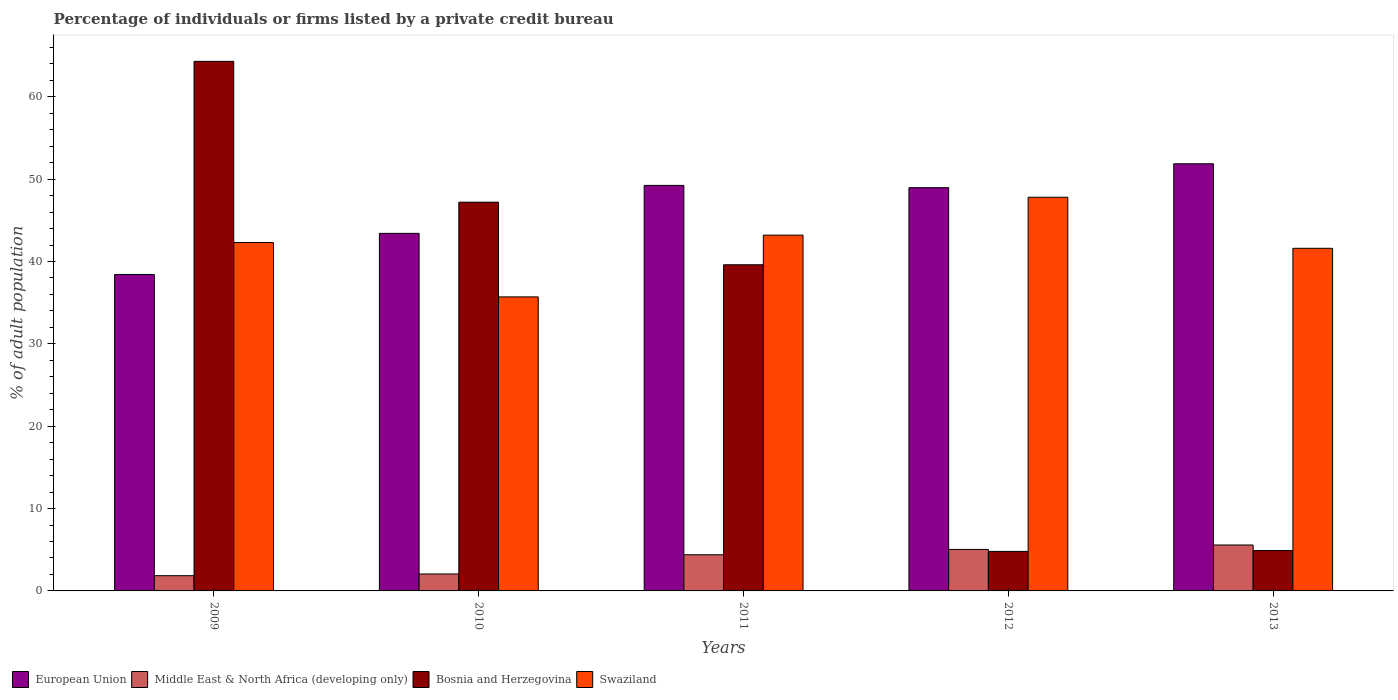How many groups of bars are there?
Your answer should be compact. 5. How many bars are there on the 3rd tick from the left?
Give a very brief answer. 4. How many bars are there on the 3rd tick from the right?
Keep it short and to the point. 4. What is the label of the 5th group of bars from the left?
Provide a short and direct response. 2013. What is the percentage of population listed by a private credit bureau in Swaziland in 2012?
Offer a very short reply. 47.8. Across all years, what is the maximum percentage of population listed by a private credit bureau in Bosnia and Herzegovina?
Provide a succinct answer. 64.3. In which year was the percentage of population listed by a private credit bureau in Swaziland maximum?
Provide a succinct answer. 2012. What is the total percentage of population listed by a private credit bureau in Bosnia and Herzegovina in the graph?
Make the answer very short. 160.8. What is the difference between the percentage of population listed by a private credit bureau in Middle East & North Africa (developing only) in 2012 and that in 2013?
Your response must be concise. -0.54. What is the difference between the percentage of population listed by a private credit bureau in European Union in 2010 and the percentage of population listed by a private credit bureau in Swaziland in 2009?
Provide a short and direct response. 1.11. What is the average percentage of population listed by a private credit bureau in Swaziland per year?
Your answer should be very brief. 42.12. In the year 2011, what is the difference between the percentage of population listed by a private credit bureau in Swaziland and percentage of population listed by a private credit bureau in European Union?
Make the answer very short. -6.04. In how many years, is the percentage of population listed by a private credit bureau in Bosnia and Herzegovina greater than 16 %?
Provide a short and direct response. 3. What is the ratio of the percentage of population listed by a private credit bureau in Swaziland in 2012 to that in 2013?
Ensure brevity in your answer.  1.15. Is the percentage of population listed by a private credit bureau in Middle East & North Africa (developing only) in 2010 less than that in 2012?
Your answer should be compact. Yes. Is the difference between the percentage of population listed by a private credit bureau in Swaziland in 2010 and 2013 greater than the difference between the percentage of population listed by a private credit bureau in European Union in 2010 and 2013?
Your answer should be compact. Yes. What is the difference between the highest and the second highest percentage of population listed by a private credit bureau in European Union?
Your response must be concise. 2.62. What is the difference between the highest and the lowest percentage of population listed by a private credit bureau in Middle East & North Africa (developing only)?
Ensure brevity in your answer.  3.73. In how many years, is the percentage of population listed by a private credit bureau in European Union greater than the average percentage of population listed by a private credit bureau in European Union taken over all years?
Ensure brevity in your answer.  3. Is the sum of the percentage of population listed by a private credit bureau in Swaziland in 2009 and 2011 greater than the maximum percentage of population listed by a private credit bureau in Bosnia and Herzegovina across all years?
Provide a short and direct response. Yes. Is it the case that in every year, the sum of the percentage of population listed by a private credit bureau in Bosnia and Herzegovina and percentage of population listed by a private credit bureau in European Union is greater than the sum of percentage of population listed by a private credit bureau in Swaziland and percentage of population listed by a private credit bureau in Middle East & North Africa (developing only)?
Provide a short and direct response. No. Are all the bars in the graph horizontal?
Offer a very short reply. No. What is the difference between two consecutive major ticks on the Y-axis?
Keep it short and to the point. 10. What is the title of the graph?
Provide a succinct answer. Percentage of individuals or firms listed by a private credit bureau. What is the label or title of the X-axis?
Give a very brief answer. Years. What is the label or title of the Y-axis?
Keep it short and to the point. % of adult population. What is the % of adult population of European Union in 2009?
Provide a short and direct response. 38.42. What is the % of adult population in Middle East & North Africa (developing only) in 2009?
Your answer should be very brief. 1.85. What is the % of adult population of Bosnia and Herzegovina in 2009?
Your response must be concise. 64.3. What is the % of adult population of Swaziland in 2009?
Offer a terse response. 42.3. What is the % of adult population in European Union in 2010?
Give a very brief answer. 43.41. What is the % of adult population in Middle East & North Africa (developing only) in 2010?
Keep it short and to the point. 2.06. What is the % of adult population of Bosnia and Herzegovina in 2010?
Make the answer very short. 47.2. What is the % of adult population of Swaziland in 2010?
Provide a succinct answer. 35.7. What is the % of adult population in European Union in 2011?
Make the answer very short. 49.24. What is the % of adult population of Middle East & North Africa (developing only) in 2011?
Make the answer very short. 4.39. What is the % of adult population in Bosnia and Herzegovina in 2011?
Provide a short and direct response. 39.6. What is the % of adult population in Swaziland in 2011?
Provide a succinct answer. 43.2. What is the % of adult population in European Union in 2012?
Offer a very short reply. 48.96. What is the % of adult population of Middle East & North Africa (developing only) in 2012?
Give a very brief answer. 5.04. What is the % of adult population of Bosnia and Herzegovina in 2012?
Provide a succinct answer. 4.8. What is the % of adult population of Swaziland in 2012?
Offer a very short reply. 47.8. What is the % of adult population in European Union in 2013?
Provide a succinct answer. 51.86. What is the % of adult population of Middle East & North Africa (developing only) in 2013?
Your response must be concise. 5.58. What is the % of adult population of Swaziland in 2013?
Your response must be concise. 41.6. Across all years, what is the maximum % of adult population of European Union?
Provide a succinct answer. 51.86. Across all years, what is the maximum % of adult population in Middle East & North Africa (developing only)?
Provide a short and direct response. 5.58. Across all years, what is the maximum % of adult population of Bosnia and Herzegovina?
Your answer should be compact. 64.3. Across all years, what is the maximum % of adult population of Swaziland?
Offer a very short reply. 47.8. Across all years, what is the minimum % of adult population of European Union?
Offer a very short reply. 38.42. Across all years, what is the minimum % of adult population in Middle East & North Africa (developing only)?
Offer a very short reply. 1.85. Across all years, what is the minimum % of adult population of Bosnia and Herzegovina?
Provide a short and direct response. 4.8. Across all years, what is the minimum % of adult population of Swaziland?
Offer a terse response. 35.7. What is the total % of adult population in European Union in the graph?
Keep it short and to the point. 231.9. What is the total % of adult population of Middle East & North Africa (developing only) in the graph?
Keep it short and to the point. 18.92. What is the total % of adult population of Bosnia and Herzegovina in the graph?
Give a very brief answer. 160.8. What is the total % of adult population of Swaziland in the graph?
Keep it short and to the point. 210.6. What is the difference between the % of adult population of European Union in 2009 and that in 2010?
Offer a very short reply. -4.99. What is the difference between the % of adult population in Middle East & North Africa (developing only) in 2009 and that in 2010?
Keep it short and to the point. -0.21. What is the difference between the % of adult population in Bosnia and Herzegovina in 2009 and that in 2010?
Your answer should be compact. 17.1. What is the difference between the % of adult population of European Union in 2009 and that in 2011?
Your answer should be compact. -10.82. What is the difference between the % of adult population of Middle East & North Africa (developing only) in 2009 and that in 2011?
Keep it short and to the point. -2.54. What is the difference between the % of adult population in Bosnia and Herzegovina in 2009 and that in 2011?
Ensure brevity in your answer.  24.7. What is the difference between the % of adult population of European Union in 2009 and that in 2012?
Your answer should be very brief. -10.54. What is the difference between the % of adult population in Middle East & North Africa (developing only) in 2009 and that in 2012?
Provide a succinct answer. -3.19. What is the difference between the % of adult population in Bosnia and Herzegovina in 2009 and that in 2012?
Provide a succinct answer. 59.5. What is the difference between the % of adult population in Swaziland in 2009 and that in 2012?
Give a very brief answer. -5.5. What is the difference between the % of adult population of European Union in 2009 and that in 2013?
Give a very brief answer. -13.44. What is the difference between the % of adult population of Middle East & North Africa (developing only) in 2009 and that in 2013?
Make the answer very short. -3.73. What is the difference between the % of adult population in Bosnia and Herzegovina in 2009 and that in 2013?
Make the answer very short. 59.4. What is the difference between the % of adult population of European Union in 2010 and that in 2011?
Offer a very short reply. -5.82. What is the difference between the % of adult population of Middle East & North Africa (developing only) in 2010 and that in 2011?
Your response must be concise. -2.33. What is the difference between the % of adult population in Bosnia and Herzegovina in 2010 and that in 2011?
Make the answer very short. 7.6. What is the difference between the % of adult population in Swaziland in 2010 and that in 2011?
Provide a succinct answer. -7.5. What is the difference between the % of adult population in European Union in 2010 and that in 2012?
Make the answer very short. -5.55. What is the difference between the % of adult population of Middle East & North Africa (developing only) in 2010 and that in 2012?
Give a very brief answer. -2.98. What is the difference between the % of adult population of Bosnia and Herzegovina in 2010 and that in 2012?
Ensure brevity in your answer.  42.4. What is the difference between the % of adult population of European Union in 2010 and that in 2013?
Give a very brief answer. -8.45. What is the difference between the % of adult population of Middle East & North Africa (developing only) in 2010 and that in 2013?
Provide a short and direct response. -3.52. What is the difference between the % of adult population in Bosnia and Herzegovina in 2010 and that in 2013?
Your answer should be compact. 42.3. What is the difference between the % of adult population of Swaziland in 2010 and that in 2013?
Make the answer very short. -5.9. What is the difference between the % of adult population of European Union in 2011 and that in 2012?
Give a very brief answer. 0.28. What is the difference between the % of adult population of Middle East & North Africa (developing only) in 2011 and that in 2012?
Offer a very short reply. -0.65. What is the difference between the % of adult population in Bosnia and Herzegovina in 2011 and that in 2012?
Offer a very short reply. 34.8. What is the difference between the % of adult population of European Union in 2011 and that in 2013?
Offer a terse response. -2.62. What is the difference between the % of adult population in Middle East & North Africa (developing only) in 2011 and that in 2013?
Offer a very short reply. -1.19. What is the difference between the % of adult population in Bosnia and Herzegovina in 2011 and that in 2013?
Your answer should be very brief. 34.7. What is the difference between the % of adult population in European Union in 2012 and that in 2013?
Your answer should be compact. -2.9. What is the difference between the % of adult population in Middle East & North Africa (developing only) in 2012 and that in 2013?
Ensure brevity in your answer.  -0.54. What is the difference between the % of adult population in European Union in 2009 and the % of adult population in Middle East & North Africa (developing only) in 2010?
Provide a short and direct response. 36.36. What is the difference between the % of adult population in European Union in 2009 and the % of adult population in Bosnia and Herzegovina in 2010?
Your answer should be very brief. -8.78. What is the difference between the % of adult population of European Union in 2009 and the % of adult population of Swaziland in 2010?
Ensure brevity in your answer.  2.72. What is the difference between the % of adult population in Middle East & North Africa (developing only) in 2009 and the % of adult population in Bosnia and Herzegovina in 2010?
Offer a very short reply. -45.35. What is the difference between the % of adult population of Middle East & North Africa (developing only) in 2009 and the % of adult population of Swaziland in 2010?
Offer a very short reply. -33.85. What is the difference between the % of adult population in Bosnia and Herzegovina in 2009 and the % of adult population in Swaziland in 2010?
Give a very brief answer. 28.6. What is the difference between the % of adult population in European Union in 2009 and the % of adult population in Middle East & North Africa (developing only) in 2011?
Ensure brevity in your answer.  34.03. What is the difference between the % of adult population of European Union in 2009 and the % of adult population of Bosnia and Herzegovina in 2011?
Provide a short and direct response. -1.18. What is the difference between the % of adult population of European Union in 2009 and the % of adult population of Swaziland in 2011?
Offer a terse response. -4.78. What is the difference between the % of adult population of Middle East & North Africa (developing only) in 2009 and the % of adult population of Bosnia and Herzegovina in 2011?
Your answer should be very brief. -37.75. What is the difference between the % of adult population of Middle East & North Africa (developing only) in 2009 and the % of adult population of Swaziland in 2011?
Offer a very short reply. -41.35. What is the difference between the % of adult population in Bosnia and Herzegovina in 2009 and the % of adult population in Swaziland in 2011?
Your response must be concise. 21.1. What is the difference between the % of adult population of European Union in 2009 and the % of adult population of Middle East & North Africa (developing only) in 2012?
Your answer should be very brief. 33.38. What is the difference between the % of adult population in European Union in 2009 and the % of adult population in Bosnia and Herzegovina in 2012?
Make the answer very short. 33.62. What is the difference between the % of adult population in European Union in 2009 and the % of adult population in Swaziland in 2012?
Your answer should be very brief. -9.38. What is the difference between the % of adult population of Middle East & North Africa (developing only) in 2009 and the % of adult population of Bosnia and Herzegovina in 2012?
Provide a short and direct response. -2.95. What is the difference between the % of adult population of Middle East & North Africa (developing only) in 2009 and the % of adult population of Swaziland in 2012?
Your answer should be compact. -45.95. What is the difference between the % of adult population of European Union in 2009 and the % of adult population of Middle East & North Africa (developing only) in 2013?
Your response must be concise. 32.85. What is the difference between the % of adult population in European Union in 2009 and the % of adult population in Bosnia and Herzegovina in 2013?
Your answer should be compact. 33.52. What is the difference between the % of adult population in European Union in 2009 and the % of adult population in Swaziland in 2013?
Give a very brief answer. -3.18. What is the difference between the % of adult population in Middle East & North Africa (developing only) in 2009 and the % of adult population in Bosnia and Herzegovina in 2013?
Keep it short and to the point. -3.05. What is the difference between the % of adult population of Middle East & North Africa (developing only) in 2009 and the % of adult population of Swaziland in 2013?
Give a very brief answer. -39.75. What is the difference between the % of adult population of Bosnia and Herzegovina in 2009 and the % of adult population of Swaziland in 2013?
Ensure brevity in your answer.  22.7. What is the difference between the % of adult population of European Union in 2010 and the % of adult population of Middle East & North Africa (developing only) in 2011?
Make the answer very short. 39.02. What is the difference between the % of adult population of European Union in 2010 and the % of adult population of Bosnia and Herzegovina in 2011?
Make the answer very short. 3.81. What is the difference between the % of adult population of European Union in 2010 and the % of adult population of Swaziland in 2011?
Your answer should be compact. 0.21. What is the difference between the % of adult population in Middle East & North Africa (developing only) in 2010 and the % of adult population in Bosnia and Herzegovina in 2011?
Offer a terse response. -37.54. What is the difference between the % of adult population of Middle East & North Africa (developing only) in 2010 and the % of adult population of Swaziland in 2011?
Your answer should be compact. -41.14. What is the difference between the % of adult population in Bosnia and Herzegovina in 2010 and the % of adult population in Swaziland in 2011?
Make the answer very short. 4. What is the difference between the % of adult population of European Union in 2010 and the % of adult population of Middle East & North Africa (developing only) in 2012?
Make the answer very short. 38.38. What is the difference between the % of adult population in European Union in 2010 and the % of adult population in Bosnia and Herzegovina in 2012?
Make the answer very short. 38.61. What is the difference between the % of adult population of European Union in 2010 and the % of adult population of Swaziland in 2012?
Offer a very short reply. -4.39. What is the difference between the % of adult population of Middle East & North Africa (developing only) in 2010 and the % of adult population of Bosnia and Herzegovina in 2012?
Provide a short and direct response. -2.74. What is the difference between the % of adult population in Middle East & North Africa (developing only) in 2010 and the % of adult population in Swaziland in 2012?
Offer a very short reply. -45.74. What is the difference between the % of adult population in Bosnia and Herzegovina in 2010 and the % of adult population in Swaziland in 2012?
Offer a very short reply. -0.6. What is the difference between the % of adult population of European Union in 2010 and the % of adult population of Middle East & North Africa (developing only) in 2013?
Offer a terse response. 37.84. What is the difference between the % of adult population in European Union in 2010 and the % of adult population in Bosnia and Herzegovina in 2013?
Provide a succinct answer. 38.51. What is the difference between the % of adult population in European Union in 2010 and the % of adult population in Swaziland in 2013?
Make the answer very short. 1.81. What is the difference between the % of adult population of Middle East & North Africa (developing only) in 2010 and the % of adult population of Bosnia and Herzegovina in 2013?
Your response must be concise. -2.84. What is the difference between the % of adult population in Middle East & North Africa (developing only) in 2010 and the % of adult population in Swaziland in 2013?
Make the answer very short. -39.54. What is the difference between the % of adult population in Bosnia and Herzegovina in 2010 and the % of adult population in Swaziland in 2013?
Your answer should be very brief. 5.6. What is the difference between the % of adult population in European Union in 2011 and the % of adult population in Middle East & North Africa (developing only) in 2012?
Your answer should be very brief. 44.2. What is the difference between the % of adult population in European Union in 2011 and the % of adult population in Bosnia and Herzegovina in 2012?
Give a very brief answer. 44.44. What is the difference between the % of adult population of European Union in 2011 and the % of adult population of Swaziland in 2012?
Your answer should be compact. 1.44. What is the difference between the % of adult population in Middle East & North Africa (developing only) in 2011 and the % of adult population in Bosnia and Herzegovina in 2012?
Ensure brevity in your answer.  -0.41. What is the difference between the % of adult population in Middle East & North Africa (developing only) in 2011 and the % of adult population in Swaziland in 2012?
Ensure brevity in your answer.  -43.41. What is the difference between the % of adult population of European Union in 2011 and the % of adult population of Middle East & North Africa (developing only) in 2013?
Your response must be concise. 43.66. What is the difference between the % of adult population in European Union in 2011 and the % of adult population in Bosnia and Herzegovina in 2013?
Your response must be concise. 44.34. What is the difference between the % of adult population of European Union in 2011 and the % of adult population of Swaziland in 2013?
Your answer should be very brief. 7.64. What is the difference between the % of adult population in Middle East & North Africa (developing only) in 2011 and the % of adult population in Bosnia and Herzegovina in 2013?
Offer a very short reply. -0.51. What is the difference between the % of adult population in Middle East & North Africa (developing only) in 2011 and the % of adult population in Swaziland in 2013?
Ensure brevity in your answer.  -37.21. What is the difference between the % of adult population in Bosnia and Herzegovina in 2011 and the % of adult population in Swaziland in 2013?
Offer a very short reply. -2. What is the difference between the % of adult population of European Union in 2012 and the % of adult population of Middle East & North Africa (developing only) in 2013?
Your response must be concise. 43.38. What is the difference between the % of adult population in European Union in 2012 and the % of adult population in Bosnia and Herzegovina in 2013?
Ensure brevity in your answer.  44.06. What is the difference between the % of adult population in European Union in 2012 and the % of adult population in Swaziland in 2013?
Your answer should be compact. 7.36. What is the difference between the % of adult population of Middle East & North Africa (developing only) in 2012 and the % of adult population of Bosnia and Herzegovina in 2013?
Ensure brevity in your answer.  0.14. What is the difference between the % of adult population in Middle East & North Africa (developing only) in 2012 and the % of adult population in Swaziland in 2013?
Keep it short and to the point. -36.56. What is the difference between the % of adult population of Bosnia and Herzegovina in 2012 and the % of adult population of Swaziland in 2013?
Your response must be concise. -36.8. What is the average % of adult population of European Union per year?
Keep it short and to the point. 46.38. What is the average % of adult population of Middle East & North Africa (developing only) per year?
Offer a very short reply. 3.78. What is the average % of adult population of Bosnia and Herzegovina per year?
Keep it short and to the point. 32.16. What is the average % of adult population of Swaziland per year?
Provide a succinct answer. 42.12. In the year 2009, what is the difference between the % of adult population of European Union and % of adult population of Middle East & North Africa (developing only)?
Make the answer very short. 36.57. In the year 2009, what is the difference between the % of adult population in European Union and % of adult population in Bosnia and Herzegovina?
Keep it short and to the point. -25.88. In the year 2009, what is the difference between the % of adult population in European Union and % of adult population in Swaziland?
Your answer should be very brief. -3.88. In the year 2009, what is the difference between the % of adult population in Middle East & North Africa (developing only) and % of adult population in Bosnia and Herzegovina?
Your answer should be compact. -62.45. In the year 2009, what is the difference between the % of adult population of Middle East & North Africa (developing only) and % of adult population of Swaziland?
Your answer should be very brief. -40.45. In the year 2009, what is the difference between the % of adult population of Bosnia and Herzegovina and % of adult population of Swaziland?
Give a very brief answer. 22. In the year 2010, what is the difference between the % of adult population of European Union and % of adult population of Middle East & North Africa (developing only)?
Your answer should be compact. 41.36. In the year 2010, what is the difference between the % of adult population in European Union and % of adult population in Bosnia and Herzegovina?
Your answer should be very brief. -3.79. In the year 2010, what is the difference between the % of adult population of European Union and % of adult population of Swaziland?
Keep it short and to the point. 7.71. In the year 2010, what is the difference between the % of adult population of Middle East & North Africa (developing only) and % of adult population of Bosnia and Herzegovina?
Your answer should be compact. -45.14. In the year 2010, what is the difference between the % of adult population of Middle East & North Africa (developing only) and % of adult population of Swaziland?
Make the answer very short. -33.64. In the year 2011, what is the difference between the % of adult population of European Union and % of adult population of Middle East & North Africa (developing only)?
Your answer should be very brief. 44.85. In the year 2011, what is the difference between the % of adult population of European Union and % of adult population of Bosnia and Herzegovina?
Make the answer very short. 9.64. In the year 2011, what is the difference between the % of adult population in European Union and % of adult population in Swaziland?
Give a very brief answer. 6.04. In the year 2011, what is the difference between the % of adult population of Middle East & North Africa (developing only) and % of adult population of Bosnia and Herzegovina?
Your answer should be very brief. -35.21. In the year 2011, what is the difference between the % of adult population of Middle East & North Africa (developing only) and % of adult population of Swaziland?
Ensure brevity in your answer.  -38.81. In the year 2012, what is the difference between the % of adult population in European Union and % of adult population in Middle East & North Africa (developing only)?
Keep it short and to the point. 43.92. In the year 2012, what is the difference between the % of adult population of European Union and % of adult population of Bosnia and Herzegovina?
Keep it short and to the point. 44.16. In the year 2012, what is the difference between the % of adult population of European Union and % of adult population of Swaziland?
Make the answer very short. 1.16. In the year 2012, what is the difference between the % of adult population of Middle East & North Africa (developing only) and % of adult population of Bosnia and Herzegovina?
Provide a short and direct response. 0.24. In the year 2012, what is the difference between the % of adult population in Middle East & North Africa (developing only) and % of adult population in Swaziland?
Provide a short and direct response. -42.76. In the year 2012, what is the difference between the % of adult population in Bosnia and Herzegovina and % of adult population in Swaziland?
Give a very brief answer. -43. In the year 2013, what is the difference between the % of adult population of European Union and % of adult population of Middle East & North Africa (developing only)?
Your answer should be compact. 46.29. In the year 2013, what is the difference between the % of adult population in European Union and % of adult population in Bosnia and Herzegovina?
Make the answer very short. 46.96. In the year 2013, what is the difference between the % of adult population in European Union and % of adult population in Swaziland?
Ensure brevity in your answer.  10.26. In the year 2013, what is the difference between the % of adult population of Middle East & North Africa (developing only) and % of adult population of Bosnia and Herzegovina?
Provide a short and direct response. 0.68. In the year 2013, what is the difference between the % of adult population in Middle East & North Africa (developing only) and % of adult population in Swaziland?
Offer a terse response. -36.02. In the year 2013, what is the difference between the % of adult population of Bosnia and Herzegovina and % of adult population of Swaziland?
Your answer should be very brief. -36.7. What is the ratio of the % of adult population in European Union in 2009 to that in 2010?
Offer a very short reply. 0.89. What is the ratio of the % of adult population in Middle East & North Africa (developing only) in 2009 to that in 2010?
Your answer should be compact. 0.9. What is the ratio of the % of adult population in Bosnia and Herzegovina in 2009 to that in 2010?
Give a very brief answer. 1.36. What is the ratio of the % of adult population of Swaziland in 2009 to that in 2010?
Give a very brief answer. 1.18. What is the ratio of the % of adult population in European Union in 2009 to that in 2011?
Your response must be concise. 0.78. What is the ratio of the % of adult population of Middle East & North Africa (developing only) in 2009 to that in 2011?
Keep it short and to the point. 0.42. What is the ratio of the % of adult population of Bosnia and Herzegovina in 2009 to that in 2011?
Provide a succinct answer. 1.62. What is the ratio of the % of adult population in Swaziland in 2009 to that in 2011?
Your answer should be very brief. 0.98. What is the ratio of the % of adult population in European Union in 2009 to that in 2012?
Your response must be concise. 0.78. What is the ratio of the % of adult population in Middle East & North Africa (developing only) in 2009 to that in 2012?
Provide a short and direct response. 0.37. What is the ratio of the % of adult population in Bosnia and Herzegovina in 2009 to that in 2012?
Offer a very short reply. 13.4. What is the ratio of the % of adult population of Swaziland in 2009 to that in 2012?
Your response must be concise. 0.88. What is the ratio of the % of adult population of European Union in 2009 to that in 2013?
Offer a very short reply. 0.74. What is the ratio of the % of adult population of Middle East & North Africa (developing only) in 2009 to that in 2013?
Your answer should be compact. 0.33. What is the ratio of the % of adult population in Bosnia and Herzegovina in 2009 to that in 2013?
Offer a terse response. 13.12. What is the ratio of the % of adult population of Swaziland in 2009 to that in 2013?
Provide a succinct answer. 1.02. What is the ratio of the % of adult population in European Union in 2010 to that in 2011?
Offer a terse response. 0.88. What is the ratio of the % of adult population of Middle East & North Africa (developing only) in 2010 to that in 2011?
Make the answer very short. 0.47. What is the ratio of the % of adult population in Bosnia and Herzegovina in 2010 to that in 2011?
Offer a very short reply. 1.19. What is the ratio of the % of adult population in Swaziland in 2010 to that in 2011?
Give a very brief answer. 0.83. What is the ratio of the % of adult population of European Union in 2010 to that in 2012?
Your response must be concise. 0.89. What is the ratio of the % of adult population of Middle East & North Africa (developing only) in 2010 to that in 2012?
Give a very brief answer. 0.41. What is the ratio of the % of adult population in Bosnia and Herzegovina in 2010 to that in 2012?
Make the answer very short. 9.83. What is the ratio of the % of adult population of Swaziland in 2010 to that in 2012?
Make the answer very short. 0.75. What is the ratio of the % of adult population in European Union in 2010 to that in 2013?
Provide a succinct answer. 0.84. What is the ratio of the % of adult population in Middle East & North Africa (developing only) in 2010 to that in 2013?
Offer a very short reply. 0.37. What is the ratio of the % of adult population in Bosnia and Herzegovina in 2010 to that in 2013?
Your answer should be very brief. 9.63. What is the ratio of the % of adult population in Swaziland in 2010 to that in 2013?
Keep it short and to the point. 0.86. What is the ratio of the % of adult population in European Union in 2011 to that in 2012?
Your answer should be compact. 1.01. What is the ratio of the % of adult population of Middle East & North Africa (developing only) in 2011 to that in 2012?
Give a very brief answer. 0.87. What is the ratio of the % of adult population in Bosnia and Herzegovina in 2011 to that in 2012?
Make the answer very short. 8.25. What is the ratio of the % of adult population of Swaziland in 2011 to that in 2012?
Your answer should be very brief. 0.9. What is the ratio of the % of adult population in European Union in 2011 to that in 2013?
Provide a succinct answer. 0.95. What is the ratio of the % of adult population of Middle East & North Africa (developing only) in 2011 to that in 2013?
Give a very brief answer. 0.79. What is the ratio of the % of adult population in Bosnia and Herzegovina in 2011 to that in 2013?
Provide a succinct answer. 8.08. What is the ratio of the % of adult population in Swaziland in 2011 to that in 2013?
Offer a very short reply. 1.04. What is the ratio of the % of adult population in European Union in 2012 to that in 2013?
Offer a very short reply. 0.94. What is the ratio of the % of adult population of Middle East & North Africa (developing only) in 2012 to that in 2013?
Offer a very short reply. 0.9. What is the ratio of the % of adult population in Bosnia and Herzegovina in 2012 to that in 2013?
Make the answer very short. 0.98. What is the ratio of the % of adult population in Swaziland in 2012 to that in 2013?
Ensure brevity in your answer.  1.15. What is the difference between the highest and the second highest % of adult population in European Union?
Offer a very short reply. 2.62. What is the difference between the highest and the second highest % of adult population in Middle East & North Africa (developing only)?
Your response must be concise. 0.54. What is the difference between the highest and the second highest % of adult population of Swaziland?
Offer a very short reply. 4.6. What is the difference between the highest and the lowest % of adult population of European Union?
Your response must be concise. 13.44. What is the difference between the highest and the lowest % of adult population of Middle East & North Africa (developing only)?
Provide a short and direct response. 3.73. What is the difference between the highest and the lowest % of adult population of Bosnia and Herzegovina?
Your answer should be compact. 59.5. What is the difference between the highest and the lowest % of adult population of Swaziland?
Offer a very short reply. 12.1. 